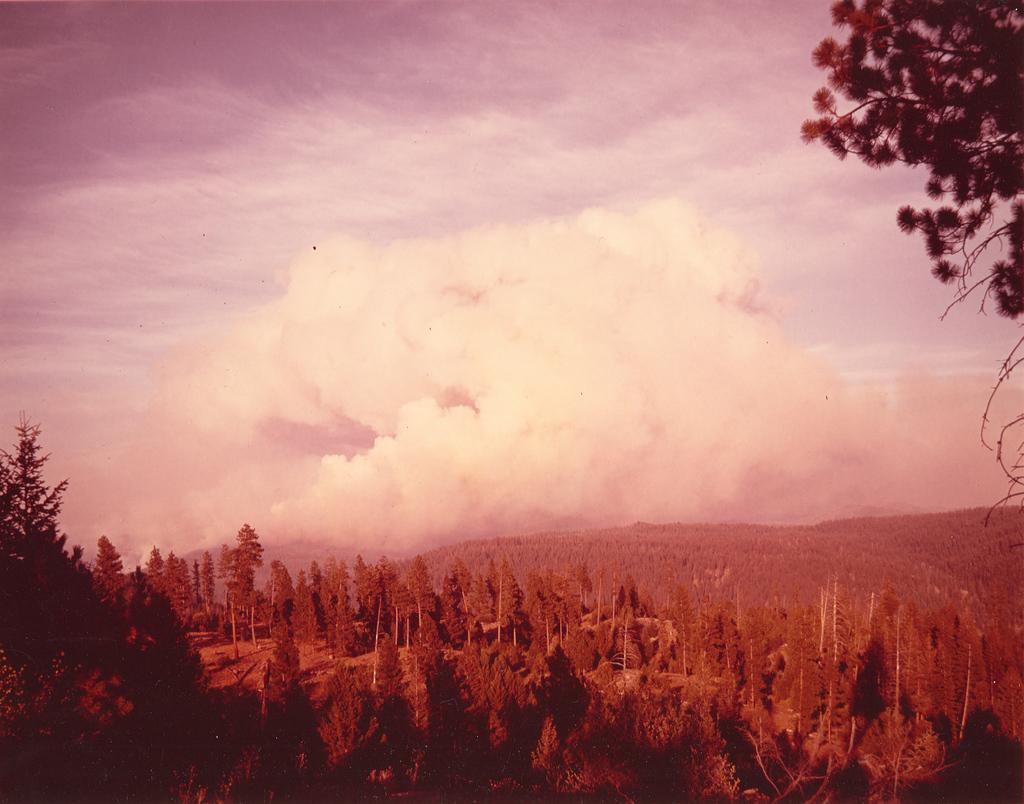Could you give a brief overview of what you see in this image? In this image we can see some trees, fog and other objects. At the top of the image there is the sky. On the right side top of the image it looks like a tree. 